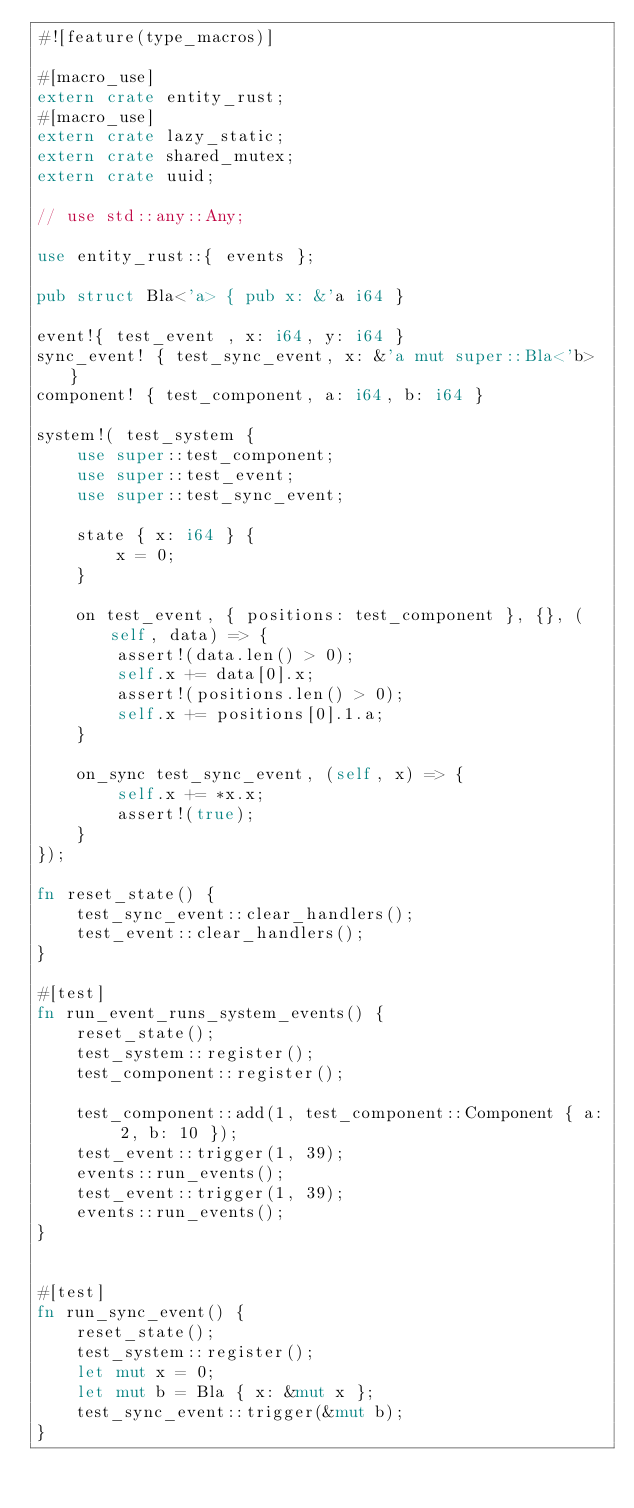Convert code to text. <code><loc_0><loc_0><loc_500><loc_500><_Rust_>#![feature(type_macros)]

#[macro_use]
extern crate entity_rust;
#[macro_use]
extern crate lazy_static;
extern crate shared_mutex;
extern crate uuid;

// use std::any::Any;

use entity_rust::{ events };

pub struct Bla<'a> { pub x: &'a i64 }

event!{ test_event , x: i64, y: i64 }
sync_event! { test_sync_event, x: &'a mut super::Bla<'b> }
component! { test_component, a: i64, b: i64 }

system!( test_system {
	use super::test_component;
	use super::test_event;
	use super::test_sync_event;

	state { x: i64 } {
		x = 0;
	}

	on test_event, { positions: test_component }, {}, (self, data) => {
		assert!(data.len() > 0);
		self.x += data[0].x;
		assert!(positions.len() > 0);
		self.x += positions[0].1.a;
	}

	on_sync test_sync_event, (self, x) => {
		self.x += *x.x;
		assert!(true);
	}
});

fn reset_state() {
	test_sync_event::clear_handlers();
	test_event::clear_handlers();
}

#[test]
fn run_event_runs_system_events() {
	reset_state();
	test_system::register();
	test_component::register();

	test_component::add(1, test_component::Component { a: 2, b: 10 });
	test_event::trigger(1, 39);
	events::run_events();
	test_event::trigger(1, 39);
	events::run_events();
}


#[test]
fn run_sync_event() {
	reset_state();
	test_system::register();
	let mut x = 0;
	let mut b = Bla { x: &mut x };
	test_sync_event::trigger(&mut b);
}
</code> 